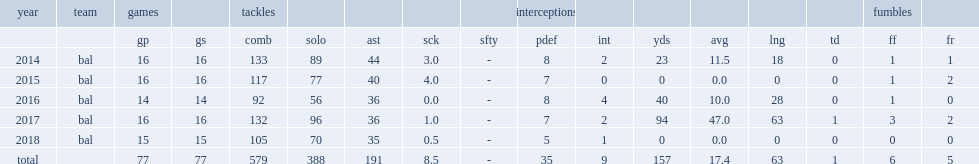When did wc. j. mosley start 16 games and record 117 combined tackles (77 solo), seven pass deflections, four sacks and a forced fumble? 2015.0. 